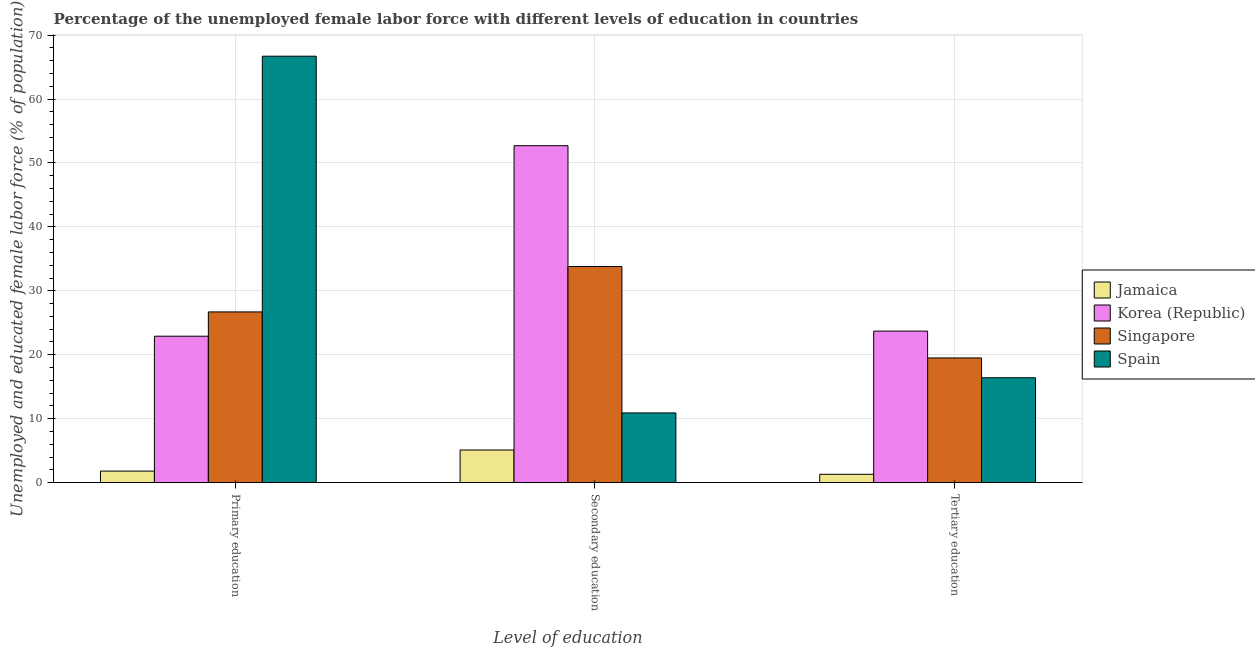How many bars are there on the 2nd tick from the left?
Offer a very short reply. 4. What is the label of the 1st group of bars from the left?
Your response must be concise. Primary education. What is the percentage of female labor force who received primary education in Spain?
Offer a very short reply. 66.7. Across all countries, what is the maximum percentage of female labor force who received primary education?
Keep it short and to the point. 66.7. Across all countries, what is the minimum percentage of female labor force who received primary education?
Keep it short and to the point. 1.8. In which country was the percentage of female labor force who received tertiary education minimum?
Your answer should be compact. Jamaica. What is the total percentage of female labor force who received primary education in the graph?
Your answer should be compact. 118.1. What is the difference between the percentage of female labor force who received primary education in Jamaica and that in Spain?
Your answer should be compact. -64.9. What is the difference between the percentage of female labor force who received secondary education in Singapore and the percentage of female labor force who received tertiary education in Jamaica?
Your response must be concise. 32.5. What is the average percentage of female labor force who received secondary education per country?
Your response must be concise. 25.62. What is the difference between the percentage of female labor force who received secondary education and percentage of female labor force who received tertiary education in Singapore?
Offer a terse response. 14.3. In how many countries, is the percentage of female labor force who received tertiary education greater than 28 %?
Your response must be concise. 0. What is the ratio of the percentage of female labor force who received tertiary education in Korea (Republic) to that in Spain?
Offer a very short reply. 1.45. Is the percentage of female labor force who received tertiary education in Jamaica less than that in Korea (Republic)?
Give a very brief answer. Yes. Is the difference between the percentage of female labor force who received primary education in Spain and Korea (Republic) greater than the difference between the percentage of female labor force who received tertiary education in Spain and Korea (Republic)?
Keep it short and to the point. Yes. What is the difference between the highest and the second highest percentage of female labor force who received secondary education?
Provide a short and direct response. 18.9. What is the difference between the highest and the lowest percentage of female labor force who received tertiary education?
Give a very brief answer. 22.4. In how many countries, is the percentage of female labor force who received tertiary education greater than the average percentage of female labor force who received tertiary education taken over all countries?
Offer a terse response. 3. What does the 4th bar from the right in Tertiary education represents?
Offer a terse response. Jamaica. Are all the bars in the graph horizontal?
Provide a succinct answer. No. What is the difference between two consecutive major ticks on the Y-axis?
Your response must be concise. 10. Are the values on the major ticks of Y-axis written in scientific E-notation?
Provide a short and direct response. No. Does the graph contain grids?
Your answer should be compact. Yes. How many legend labels are there?
Your answer should be compact. 4. What is the title of the graph?
Offer a terse response. Percentage of the unemployed female labor force with different levels of education in countries. Does "San Marino" appear as one of the legend labels in the graph?
Offer a very short reply. No. What is the label or title of the X-axis?
Provide a short and direct response. Level of education. What is the label or title of the Y-axis?
Provide a succinct answer. Unemployed and educated female labor force (% of population). What is the Unemployed and educated female labor force (% of population) of Jamaica in Primary education?
Offer a very short reply. 1.8. What is the Unemployed and educated female labor force (% of population) of Korea (Republic) in Primary education?
Your answer should be compact. 22.9. What is the Unemployed and educated female labor force (% of population) in Singapore in Primary education?
Ensure brevity in your answer.  26.7. What is the Unemployed and educated female labor force (% of population) in Spain in Primary education?
Your answer should be compact. 66.7. What is the Unemployed and educated female labor force (% of population) in Jamaica in Secondary education?
Your answer should be very brief. 5.1. What is the Unemployed and educated female labor force (% of population) in Korea (Republic) in Secondary education?
Offer a terse response. 52.7. What is the Unemployed and educated female labor force (% of population) of Singapore in Secondary education?
Provide a short and direct response. 33.8. What is the Unemployed and educated female labor force (% of population) of Spain in Secondary education?
Offer a terse response. 10.9. What is the Unemployed and educated female labor force (% of population) in Jamaica in Tertiary education?
Offer a very short reply. 1.3. What is the Unemployed and educated female labor force (% of population) of Korea (Republic) in Tertiary education?
Your answer should be compact. 23.7. What is the Unemployed and educated female labor force (% of population) in Spain in Tertiary education?
Your response must be concise. 16.4. Across all Level of education, what is the maximum Unemployed and educated female labor force (% of population) in Jamaica?
Make the answer very short. 5.1. Across all Level of education, what is the maximum Unemployed and educated female labor force (% of population) of Korea (Republic)?
Your answer should be compact. 52.7. Across all Level of education, what is the maximum Unemployed and educated female labor force (% of population) in Singapore?
Ensure brevity in your answer.  33.8. Across all Level of education, what is the maximum Unemployed and educated female labor force (% of population) in Spain?
Your answer should be compact. 66.7. Across all Level of education, what is the minimum Unemployed and educated female labor force (% of population) of Jamaica?
Offer a very short reply. 1.3. Across all Level of education, what is the minimum Unemployed and educated female labor force (% of population) of Korea (Republic)?
Give a very brief answer. 22.9. Across all Level of education, what is the minimum Unemployed and educated female labor force (% of population) of Spain?
Your answer should be compact. 10.9. What is the total Unemployed and educated female labor force (% of population) of Korea (Republic) in the graph?
Offer a very short reply. 99.3. What is the total Unemployed and educated female labor force (% of population) of Singapore in the graph?
Offer a very short reply. 80. What is the total Unemployed and educated female labor force (% of population) in Spain in the graph?
Ensure brevity in your answer.  94. What is the difference between the Unemployed and educated female labor force (% of population) in Korea (Republic) in Primary education and that in Secondary education?
Ensure brevity in your answer.  -29.8. What is the difference between the Unemployed and educated female labor force (% of population) in Singapore in Primary education and that in Secondary education?
Your response must be concise. -7.1. What is the difference between the Unemployed and educated female labor force (% of population) in Spain in Primary education and that in Secondary education?
Provide a short and direct response. 55.8. What is the difference between the Unemployed and educated female labor force (% of population) of Korea (Republic) in Primary education and that in Tertiary education?
Ensure brevity in your answer.  -0.8. What is the difference between the Unemployed and educated female labor force (% of population) of Singapore in Primary education and that in Tertiary education?
Your answer should be compact. 7.2. What is the difference between the Unemployed and educated female labor force (% of population) in Spain in Primary education and that in Tertiary education?
Keep it short and to the point. 50.3. What is the difference between the Unemployed and educated female labor force (% of population) in Jamaica in Secondary education and that in Tertiary education?
Give a very brief answer. 3.8. What is the difference between the Unemployed and educated female labor force (% of population) of Korea (Republic) in Secondary education and that in Tertiary education?
Your answer should be very brief. 29. What is the difference between the Unemployed and educated female labor force (% of population) in Singapore in Secondary education and that in Tertiary education?
Ensure brevity in your answer.  14.3. What is the difference between the Unemployed and educated female labor force (% of population) in Spain in Secondary education and that in Tertiary education?
Offer a terse response. -5.5. What is the difference between the Unemployed and educated female labor force (% of population) in Jamaica in Primary education and the Unemployed and educated female labor force (% of population) in Korea (Republic) in Secondary education?
Provide a succinct answer. -50.9. What is the difference between the Unemployed and educated female labor force (% of population) in Jamaica in Primary education and the Unemployed and educated female labor force (% of population) in Singapore in Secondary education?
Offer a very short reply. -32. What is the difference between the Unemployed and educated female labor force (% of population) in Jamaica in Primary education and the Unemployed and educated female labor force (% of population) in Spain in Secondary education?
Offer a very short reply. -9.1. What is the difference between the Unemployed and educated female labor force (% of population) in Korea (Republic) in Primary education and the Unemployed and educated female labor force (% of population) in Spain in Secondary education?
Provide a succinct answer. 12. What is the difference between the Unemployed and educated female labor force (% of population) in Jamaica in Primary education and the Unemployed and educated female labor force (% of population) in Korea (Republic) in Tertiary education?
Your response must be concise. -21.9. What is the difference between the Unemployed and educated female labor force (% of population) of Jamaica in Primary education and the Unemployed and educated female labor force (% of population) of Singapore in Tertiary education?
Ensure brevity in your answer.  -17.7. What is the difference between the Unemployed and educated female labor force (% of population) of Jamaica in Primary education and the Unemployed and educated female labor force (% of population) of Spain in Tertiary education?
Keep it short and to the point. -14.6. What is the difference between the Unemployed and educated female labor force (% of population) in Korea (Republic) in Primary education and the Unemployed and educated female labor force (% of population) in Singapore in Tertiary education?
Your answer should be compact. 3.4. What is the difference between the Unemployed and educated female labor force (% of population) in Korea (Republic) in Primary education and the Unemployed and educated female labor force (% of population) in Spain in Tertiary education?
Your response must be concise. 6.5. What is the difference between the Unemployed and educated female labor force (% of population) of Jamaica in Secondary education and the Unemployed and educated female labor force (% of population) of Korea (Republic) in Tertiary education?
Provide a short and direct response. -18.6. What is the difference between the Unemployed and educated female labor force (% of population) of Jamaica in Secondary education and the Unemployed and educated female labor force (% of population) of Singapore in Tertiary education?
Your answer should be very brief. -14.4. What is the difference between the Unemployed and educated female labor force (% of population) of Korea (Republic) in Secondary education and the Unemployed and educated female labor force (% of population) of Singapore in Tertiary education?
Ensure brevity in your answer.  33.2. What is the difference between the Unemployed and educated female labor force (% of population) of Korea (Republic) in Secondary education and the Unemployed and educated female labor force (% of population) of Spain in Tertiary education?
Your answer should be very brief. 36.3. What is the difference between the Unemployed and educated female labor force (% of population) of Singapore in Secondary education and the Unemployed and educated female labor force (% of population) of Spain in Tertiary education?
Your answer should be compact. 17.4. What is the average Unemployed and educated female labor force (% of population) in Jamaica per Level of education?
Provide a short and direct response. 2.73. What is the average Unemployed and educated female labor force (% of population) of Korea (Republic) per Level of education?
Ensure brevity in your answer.  33.1. What is the average Unemployed and educated female labor force (% of population) of Singapore per Level of education?
Give a very brief answer. 26.67. What is the average Unemployed and educated female labor force (% of population) in Spain per Level of education?
Provide a succinct answer. 31.33. What is the difference between the Unemployed and educated female labor force (% of population) of Jamaica and Unemployed and educated female labor force (% of population) of Korea (Republic) in Primary education?
Offer a very short reply. -21.1. What is the difference between the Unemployed and educated female labor force (% of population) of Jamaica and Unemployed and educated female labor force (% of population) of Singapore in Primary education?
Provide a succinct answer. -24.9. What is the difference between the Unemployed and educated female labor force (% of population) in Jamaica and Unemployed and educated female labor force (% of population) in Spain in Primary education?
Give a very brief answer. -64.9. What is the difference between the Unemployed and educated female labor force (% of population) in Korea (Republic) and Unemployed and educated female labor force (% of population) in Singapore in Primary education?
Ensure brevity in your answer.  -3.8. What is the difference between the Unemployed and educated female labor force (% of population) in Korea (Republic) and Unemployed and educated female labor force (% of population) in Spain in Primary education?
Keep it short and to the point. -43.8. What is the difference between the Unemployed and educated female labor force (% of population) in Singapore and Unemployed and educated female labor force (% of population) in Spain in Primary education?
Provide a short and direct response. -40. What is the difference between the Unemployed and educated female labor force (% of population) in Jamaica and Unemployed and educated female labor force (% of population) in Korea (Republic) in Secondary education?
Your response must be concise. -47.6. What is the difference between the Unemployed and educated female labor force (% of population) in Jamaica and Unemployed and educated female labor force (% of population) in Singapore in Secondary education?
Keep it short and to the point. -28.7. What is the difference between the Unemployed and educated female labor force (% of population) in Korea (Republic) and Unemployed and educated female labor force (% of population) in Spain in Secondary education?
Your answer should be very brief. 41.8. What is the difference between the Unemployed and educated female labor force (% of population) in Singapore and Unemployed and educated female labor force (% of population) in Spain in Secondary education?
Ensure brevity in your answer.  22.9. What is the difference between the Unemployed and educated female labor force (% of population) in Jamaica and Unemployed and educated female labor force (% of population) in Korea (Republic) in Tertiary education?
Give a very brief answer. -22.4. What is the difference between the Unemployed and educated female labor force (% of population) of Jamaica and Unemployed and educated female labor force (% of population) of Singapore in Tertiary education?
Provide a succinct answer. -18.2. What is the difference between the Unemployed and educated female labor force (% of population) in Jamaica and Unemployed and educated female labor force (% of population) in Spain in Tertiary education?
Offer a terse response. -15.1. What is the difference between the Unemployed and educated female labor force (% of population) of Singapore and Unemployed and educated female labor force (% of population) of Spain in Tertiary education?
Your response must be concise. 3.1. What is the ratio of the Unemployed and educated female labor force (% of population) in Jamaica in Primary education to that in Secondary education?
Your answer should be compact. 0.35. What is the ratio of the Unemployed and educated female labor force (% of population) of Korea (Republic) in Primary education to that in Secondary education?
Your answer should be compact. 0.43. What is the ratio of the Unemployed and educated female labor force (% of population) of Singapore in Primary education to that in Secondary education?
Your answer should be compact. 0.79. What is the ratio of the Unemployed and educated female labor force (% of population) in Spain in Primary education to that in Secondary education?
Your answer should be compact. 6.12. What is the ratio of the Unemployed and educated female labor force (% of population) of Jamaica in Primary education to that in Tertiary education?
Your answer should be compact. 1.38. What is the ratio of the Unemployed and educated female labor force (% of population) in Korea (Republic) in Primary education to that in Tertiary education?
Ensure brevity in your answer.  0.97. What is the ratio of the Unemployed and educated female labor force (% of population) in Singapore in Primary education to that in Tertiary education?
Give a very brief answer. 1.37. What is the ratio of the Unemployed and educated female labor force (% of population) in Spain in Primary education to that in Tertiary education?
Offer a terse response. 4.07. What is the ratio of the Unemployed and educated female labor force (% of population) in Jamaica in Secondary education to that in Tertiary education?
Your answer should be compact. 3.92. What is the ratio of the Unemployed and educated female labor force (% of population) of Korea (Republic) in Secondary education to that in Tertiary education?
Provide a succinct answer. 2.22. What is the ratio of the Unemployed and educated female labor force (% of population) in Singapore in Secondary education to that in Tertiary education?
Your answer should be very brief. 1.73. What is the ratio of the Unemployed and educated female labor force (% of population) in Spain in Secondary education to that in Tertiary education?
Give a very brief answer. 0.66. What is the difference between the highest and the second highest Unemployed and educated female labor force (% of population) in Korea (Republic)?
Keep it short and to the point. 29. What is the difference between the highest and the second highest Unemployed and educated female labor force (% of population) in Singapore?
Provide a succinct answer. 7.1. What is the difference between the highest and the second highest Unemployed and educated female labor force (% of population) of Spain?
Offer a very short reply. 50.3. What is the difference between the highest and the lowest Unemployed and educated female labor force (% of population) in Jamaica?
Your response must be concise. 3.8. What is the difference between the highest and the lowest Unemployed and educated female labor force (% of population) in Korea (Republic)?
Your answer should be compact. 29.8. What is the difference between the highest and the lowest Unemployed and educated female labor force (% of population) of Singapore?
Your answer should be very brief. 14.3. What is the difference between the highest and the lowest Unemployed and educated female labor force (% of population) of Spain?
Your response must be concise. 55.8. 